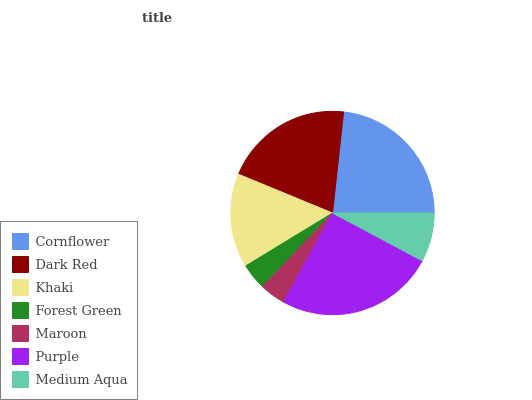Is Maroon the minimum?
Answer yes or no. Yes. Is Purple the maximum?
Answer yes or no. Yes. Is Dark Red the minimum?
Answer yes or no. No. Is Dark Red the maximum?
Answer yes or no. No. Is Cornflower greater than Dark Red?
Answer yes or no. Yes. Is Dark Red less than Cornflower?
Answer yes or no. Yes. Is Dark Red greater than Cornflower?
Answer yes or no. No. Is Cornflower less than Dark Red?
Answer yes or no. No. Is Khaki the high median?
Answer yes or no. Yes. Is Khaki the low median?
Answer yes or no. Yes. Is Cornflower the high median?
Answer yes or no. No. Is Dark Red the low median?
Answer yes or no. No. 